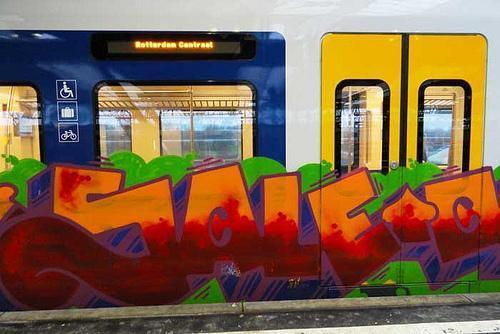How many doors are there?
Give a very brief answer. 1. 